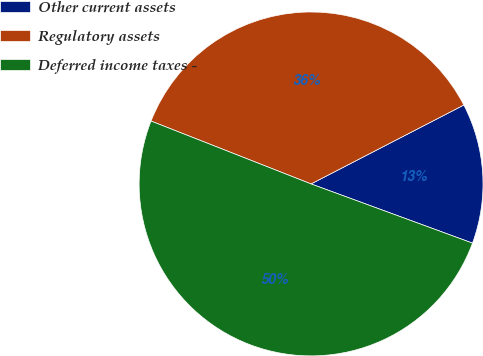Convert chart to OTSL. <chart><loc_0><loc_0><loc_500><loc_500><pie_chart><fcel>Other current assets<fcel>Regulatory assets<fcel>Deferred income taxes -<nl><fcel>13.18%<fcel>36.45%<fcel>50.36%<nl></chart> 